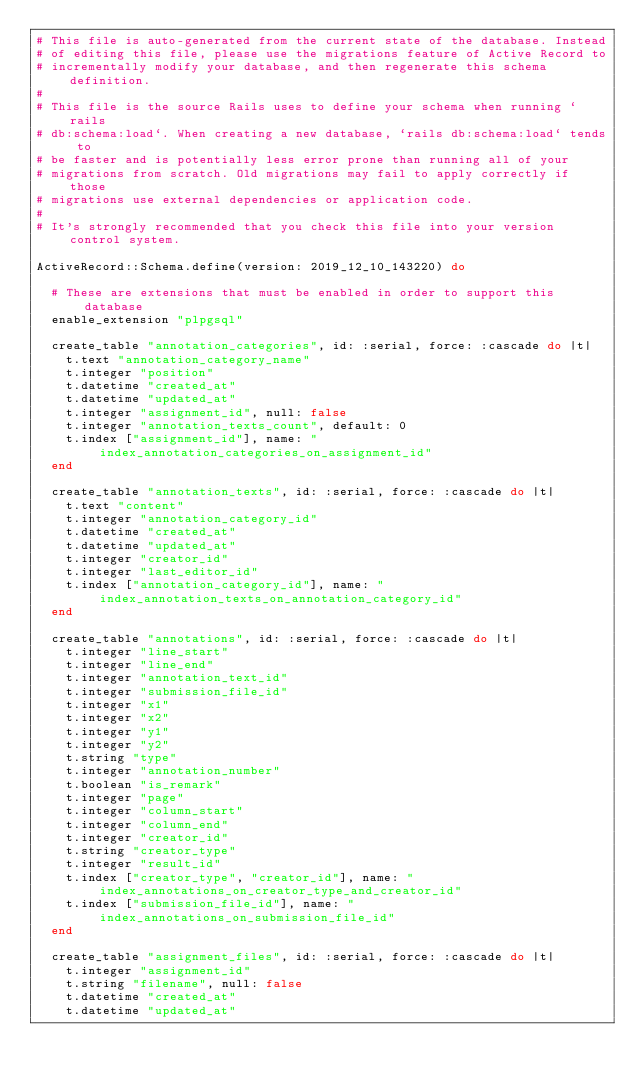Convert code to text. <code><loc_0><loc_0><loc_500><loc_500><_Ruby_># This file is auto-generated from the current state of the database. Instead
# of editing this file, please use the migrations feature of Active Record to
# incrementally modify your database, and then regenerate this schema definition.
#
# This file is the source Rails uses to define your schema when running `rails
# db:schema:load`. When creating a new database, `rails db:schema:load` tends to
# be faster and is potentially less error prone than running all of your
# migrations from scratch. Old migrations may fail to apply correctly if those
# migrations use external dependencies or application code.
#
# It's strongly recommended that you check this file into your version control system.

ActiveRecord::Schema.define(version: 2019_12_10_143220) do

  # These are extensions that must be enabled in order to support this database
  enable_extension "plpgsql"

  create_table "annotation_categories", id: :serial, force: :cascade do |t|
    t.text "annotation_category_name"
    t.integer "position"
    t.datetime "created_at"
    t.datetime "updated_at"
    t.integer "assignment_id", null: false
    t.integer "annotation_texts_count", default: 0
    t.index ["assignment_id"], name: "index_annotation_categories_on_assignment_id"
  end

  create_table "annotation_texts", id: :serial, force: :cascade do |t|
    t.text "content"
    t.integer "annotation_category_id"
    t.datetime "created_at"
    t.datetime "updated_at"
    t.integer "creator_id"
    t.integer "last_editor_id"
    t.index ["annotation_category_id"], name: "index_annotation_texts_on_annotation_category_id"
  end

  create_table "annotations", id: :serial, force: :cascade do |t|
    t.integer "line_start"
    t.integer "line_end"
    t.integer "annotation_text_id"
    t.integer "submission_file_id"
    t.integer "x1"
    t.integer "x2"
    t.integer "y1"
    t.integer "y2"
    t.string "type"
    t.integer "annotation_number"
    t.boolean "is_remark"
    t.integer "page"
    t.integer "column_start"
    t.integer "column_end"
    t.integer "creator_id"
    t.string "creator_type"
    t.integer "result_id"
    t.index ["creator_type", "creator_id"], name: "index_annotations_on_creator_type_and_creator_id"
    t.index ["submission_file_id"], name: "index_annotations_on_submission_file_id"
  end

  create_table "assignment_files", id: :serial, force: :cascade do |t|
    t.integer "assignment_id"
    t.string "filename", null: false
    t.datetime "created_at"
    t.datetime "updated_at"</code> 